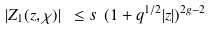<formula> <loc_0><loc_0><loc_500><loc_500>| Z _ { 1 } ( z , \chi ) | \ \leq s \ ( 1 + q ^ { 1 / 2 } | z | ) ^ { 2 g - 2 }</formula> 